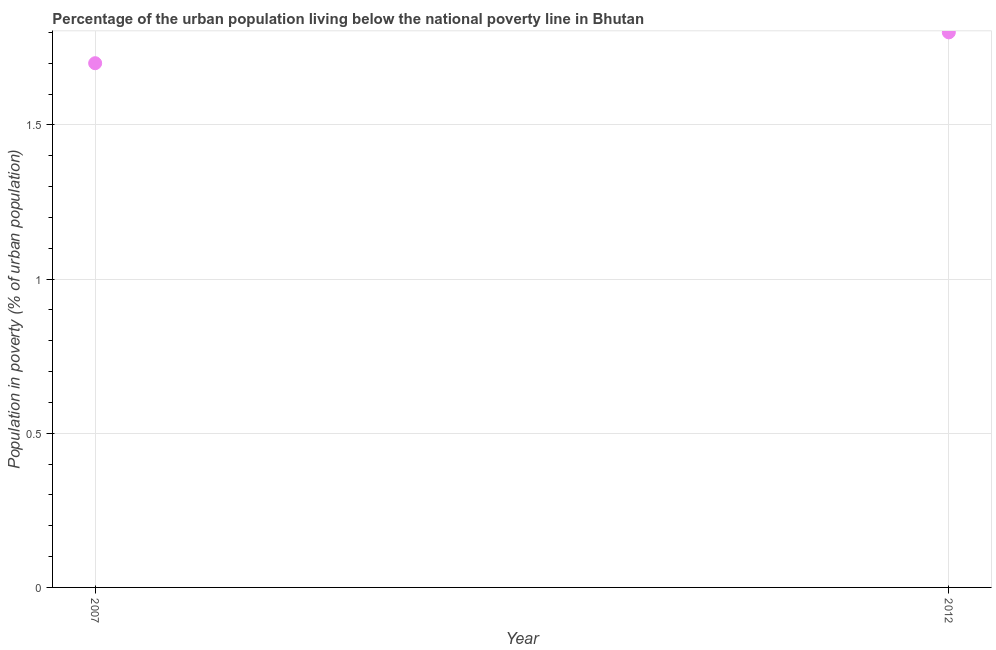What is the percentage of urban population living below poverty line in 2007?
Your answer should be very brief. 1.7. In which year was the percentage of urban population living below poverty line maximum?
Your response must be concise. 2012. In which year was the percentage of urban population living below poverty line minimum?
Give a very brief answer. 2007. What is the difference between the percentage of urban population living below poverty line in 2007 and 2012?
Provide a short and direct response. -0.1. What is the median percentage of urban population living below poverty line?
Your answer should be very brief. 1.75. Do a majority of the years between 2007 and 2012 (inclusive) have percentage of urban population living below poverty line greater than 0.1 %?
Ensure brevity in your answer.  Yes. What is the ratio of the percentage of urban population living below poverty line in 2007 to that in 2012?
Your response must be concise. 0.94. How many dotlines are there?
Offer a terse response. 1. Are the values on the major ticks of Y-axis written in scientific E-notation?
Your response must be concise. No. What is the title of the graph?
Offer a terse response. Percentage of the urban population living below the national poverty line in Bhutan. What is the label or title of the X-axis?
Offer a very short reply. Year. What is the label or title of the Y-axis?
Offer a very short reply. Population in poverty (% of urban population). What is the Population in poverty (% of urban population) in 2012?
Ensure brevity in your answer.  1.8. What is the difference between the Population in poverty (% of urban population) in 2007 and 2012?
Your response must be concise. -0.1. What is the ratio of the Population in poverty (% of urban population) in 2007 to that in 2012?
Your answer should be very brief. 0.94. 